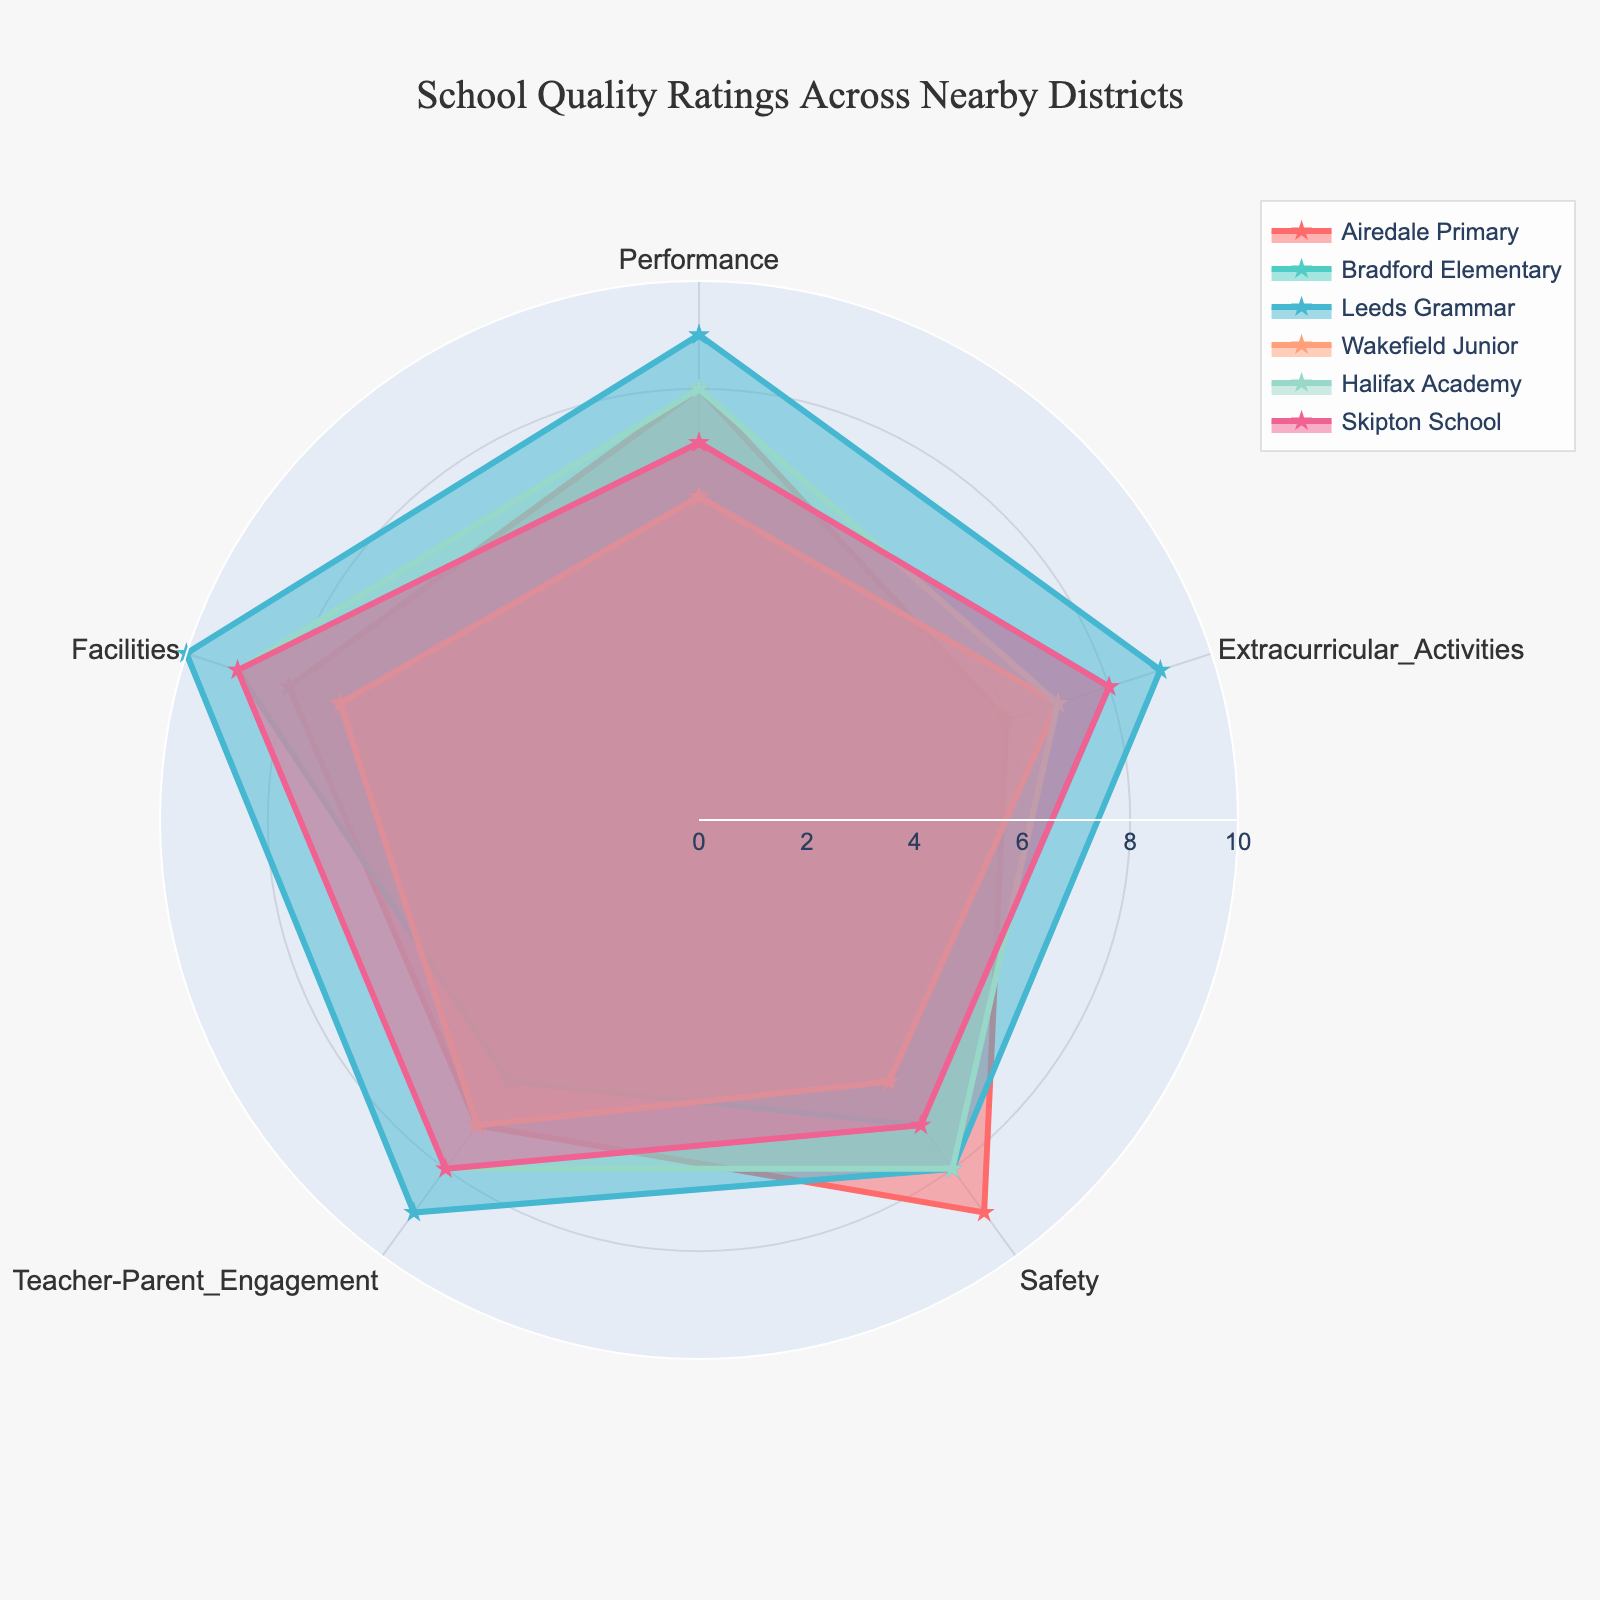What's the title of the plot? The title of the plot is located at the top of the chart and it helps in quickly identifying the main subject of the plot.
Answer: School Quality Ratings Across Nearby Districts What are the five categories used in the radar chart? The categories are listed on the axes of the radar chart and each axis represents a different category being evaluated.
Answer: Performance, Extracurricular Activities, Safety, Teacher-Parent Engagement, Facilities Which school has the highest rating for "Teacher-Parent Engagement"? Look at the plotted points for "Teacher-Parent Engagement" on the radar chart and identify which school reaches the highest mark.
Answer: Leeds Grammar Compare the Safety ratings between Airedale Primary and Wakefield Junior. Which one is rated higher and by how much? Identify and compare the location of the plotted points for "Safety" for both Airedale Primary and Wakefield Junior. Airedale Primary is rated at 9, and Wakefield Junior at 6. The difference is 9-6=3.
Answer: Airedale Primary by 3 Which school has the lowest rating for Performance and what is the rating? Look at the plotted points for "Performance" and find the school with the lowest value.
Answer: Wakefield Junior, 6 Which two schools have the closest overall ratings in all categories? Look around the radar chart to see which two schools' plots overlap or are very close to each other in multiple categories. Consider multiple factors like Performance, Extracurricular Activities, Safety, Teacher-Parent Engagement, and Facilities.
Answer: Skipton School and Bradford Elementary What's the difference between the highest and lowest rating for Facilities among all schools? Locate the highest and lowest points for the "Facilities" category on the radar chart. Leeds Grammar has the highest (10), and Wakefield Junior the lowest (7). The difference is 10-7=3.
Answer: 3 How does Airedale Primary compare to Halifax Academy in Extracurricular Activities? Consult the points for "Extracurricular Activities" of both Airedale Primary and Halifax Academy to determine which one has the higher rating. Airedale Primary is rated at 6, and Halifax Academy at 7.
Answer: Halifax Academy is higher by 1 What's the total sum of ratings for Leeds Grammar? Add up the ratings given in all five categories for Leeds Grammar. The numbers are 9 (Performance) + 9 (Extracurricular Activities) + 8 (Safety) + 9 (Teacher-Parent Engagement) + 10 (Facilities) = 45.
Answer: 45 